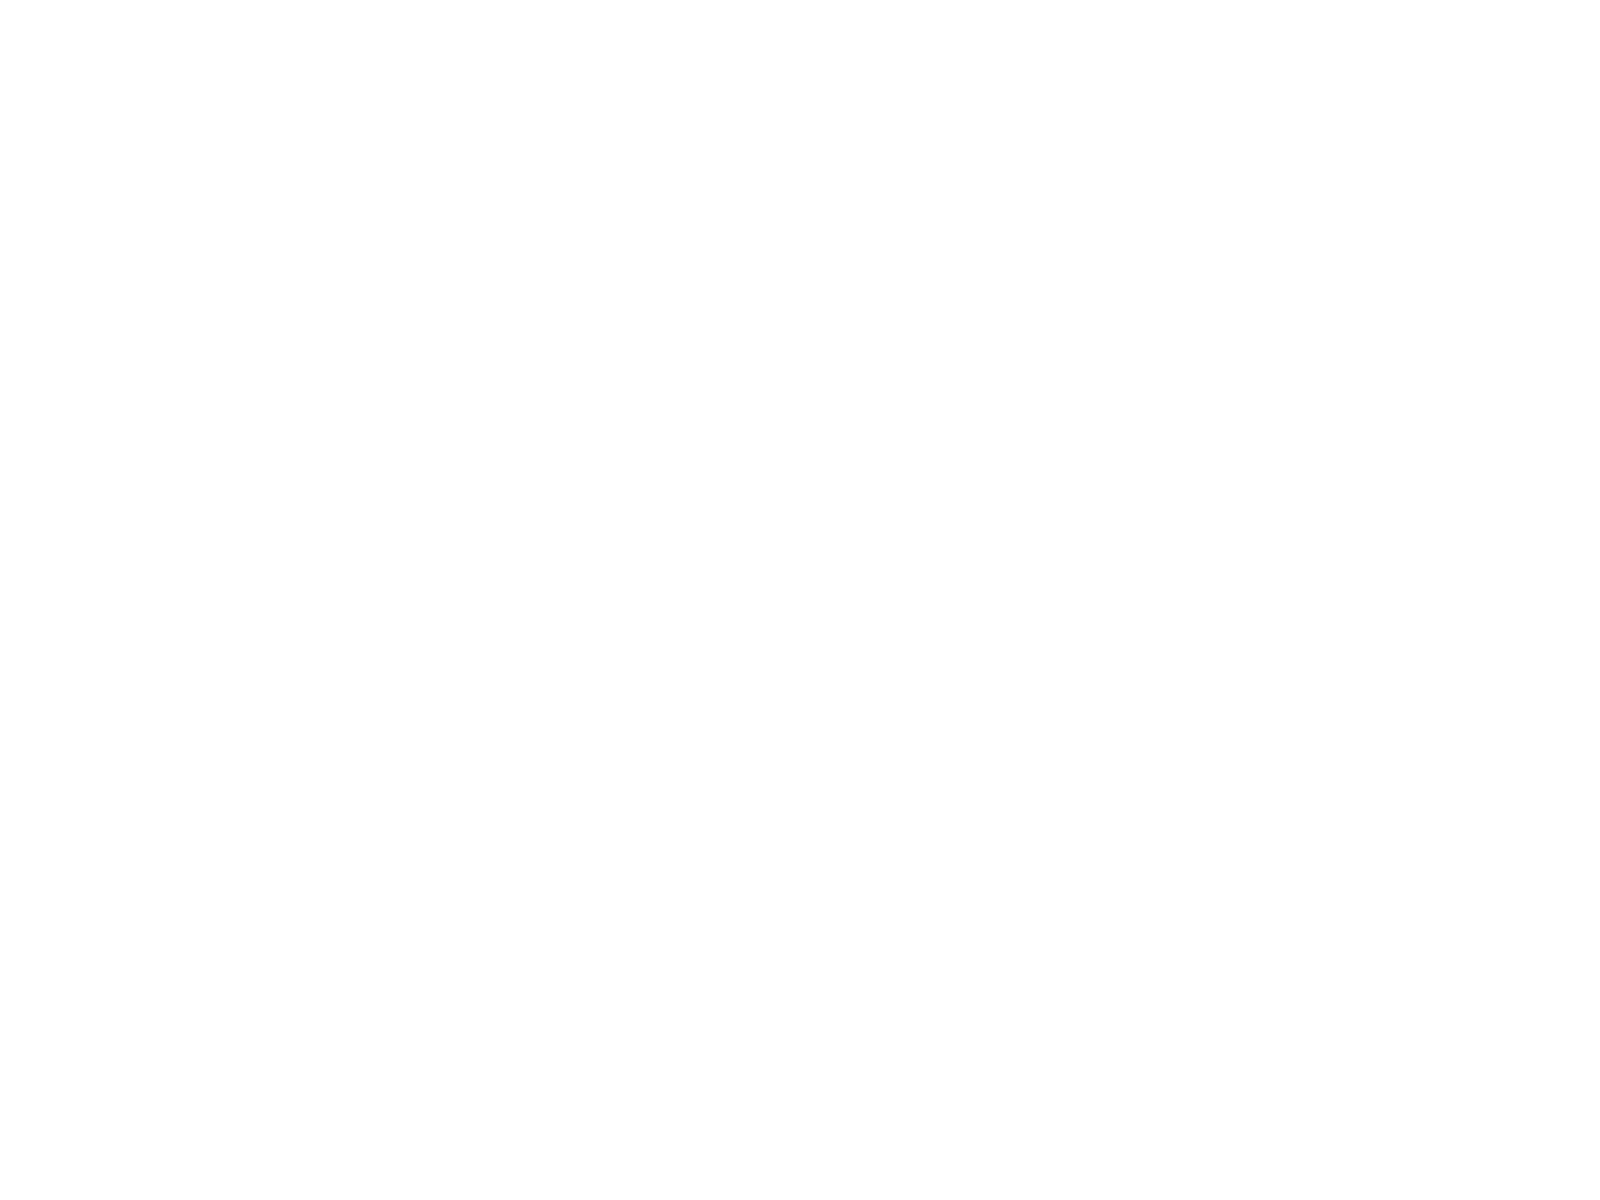Convert chart to OTSL. <chart><loc_0><loc_0><loc_500><loc_500><pie_chart><fcel>Interest rates<fcel>Exchange-traded<fcel>OTC-cleared<fcel>Bilateral OTC<fcel>Credit<fcel>Currencies<fcel>Commodities<fcel>Equities<fcel>Subtotal<nl><fcel>19.62%<fcel>0.01%<fcel>12.96%<fcel>15.55%<fcel>5.19%<fcel>10.37%<fcel>2.6%<fcel>7.78%<fcel>25.92%<nl></chart> 